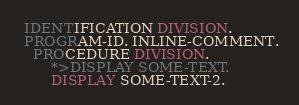<code> <loc_0><loc_0><loc_500><loc_500><_COBOL_> IDENTIFICATION DIVISION.
 PROGRAM-ID. INLINE-COMMENT.
   PROCEDURE DIVISION.
       *>DISPLAY SOME-TEXT.
       DISPLAY SOME-TEXT-2.</code> 